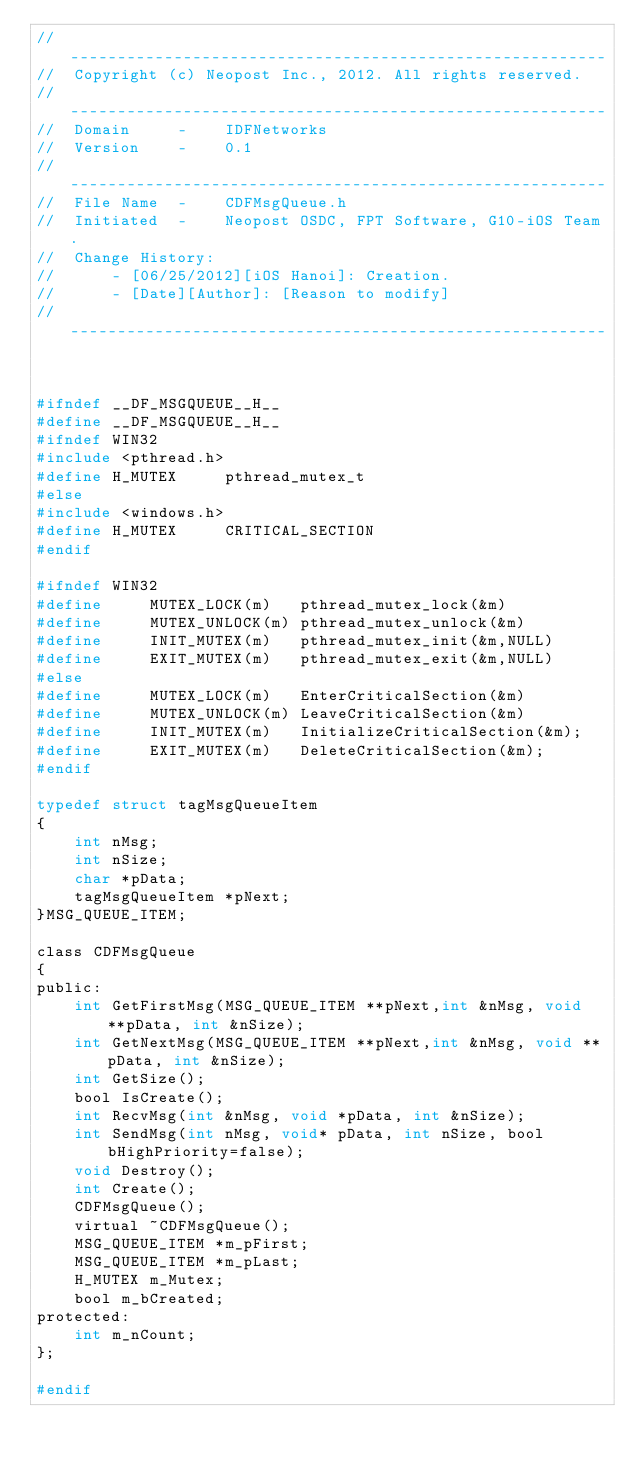Convert code to text. <code><loc_0><loc_0><loc_500><loc_500><_C_>//  ---------------------------------------------------------
//  Copyright (c) Neopost Inc., 2012. All rights reserved.   
//  ---------------------------------------------------------
//  Domain     -    IDFNetworks
//  Version    -    0.1
//  ---------------------------------------------------------
//  File Name  -    CDFMsgQueue.h
//  Initiated  -    Neopost OSDC, FPT Software, G10-iOS Team.
//  Change History: 
//      - [06/25/2012][iOS Hanoi]: Creation.
//      - [Date][Author]: [Reason to modify]
//  ---------------------------------------------------------



#ifndef __DF_MSGQUEUE__H__
#define __DF_MSGQUEUE__H__
#ifndef WIN32
#include <pthread.h>
#define	H_MUTEX		pthread_mutex_t
#else
#include <windows.h>
#define	H_MUTEX		CRITICAL_SECTION	
#endif

#ifndef WIN32
#define		MUTEX_LOCK(m)   pthread_mutex_lock(&m)
#define		MUTEX_UNLOCK(m) pthread_mutex_unlock(&m)
#define		INIT_MUTEX(m)   pthread_mutex_init(&m,NULL)
#define		EXIT_MUTEX(m)   pthread_mutex_exit(&m,NULL)
#else
#define		MUTEX_LOCK(m)   EnterCriticalSection(&m)
#define		MUTEX_UNLOCK(m) LeaveCriticalSection(&m)
#define		INIT_MUTEX(m)   InitializeCriticalSection(&m);
#define		EXIT_MUTEX(m)   DeleteCriticalSection(&m);
#endif

typedef struct tagMsgQueueItem
{
	int nMsg;
	int nSize;
	char *pData;
	tagMsgQueueItem *pNext;	
}MSG_QUEUE_ITEM;

class CDFMsgQueue  
{
public:
	int GetFirstMsg(MSG_QUEUE_ITEM **pNext,int &nMsg, void **pData, int &nSize);
	int GetNextMsg(MSG_QUEUE_ITEM **pNext,int &nMsg, void **pData, int &nSize);
	int GetSize();
	bool IsCreate();
	int RecvMsg(int &nMsg, void *pData, int &nSize);
	int SendMsg(int nMsg, void* pData, int nSize, bool bHighPriority=false);
	void Destroy();
	int Create();
	CDFMsgQueue();
	virtual ~CDFMsgQueue();
	MSG_QUEUE_ITEM *m_pFirst;
	MSG_QUEUE_ITEM *m_pLast;
	H_MUTEX m_Mutex;
	bool m_bCreated;
protected:
	int m_nCount;
};

#endif</code> 